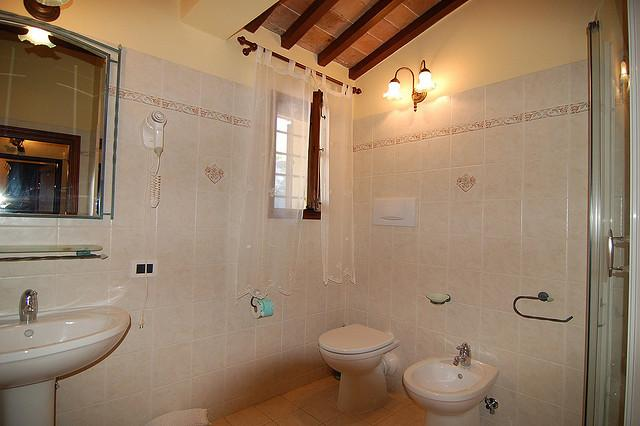How many places could an animal get water from here?

Choices:
A) three
B) five
C) eight
D) six three 